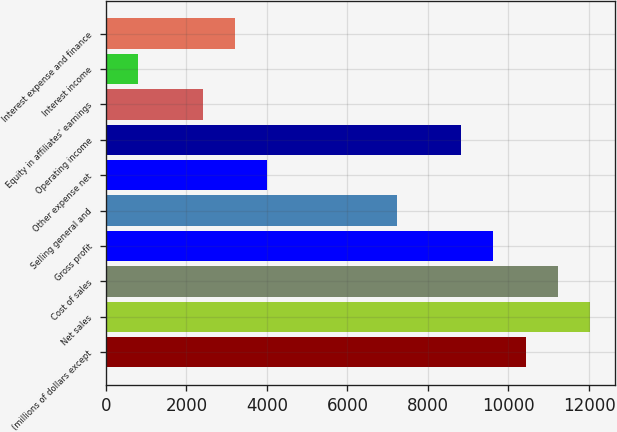<chart> <loc_0><loc_0><loc_500><loc_500><bar_chart><fcel>(millions of dollars except<fcel>Net sales<fcel>Cost of sales<fcel>Gross profit<fcel>Selling general and<fcel>Other expense net<fcel>Operating income<fcel>Equity in affiliates' earnings<fcel>Interest income<fcel>Interest expense and finance<nl><fcel>10429.4<fcel>12033.5<fcel>11231.4<fcel>9627.3<fcel>7221.15<fcel>4012.95<fcel>8825.25<fcel>2408.85<fcel>804.75<fcel>3210.9<nl></chart> 